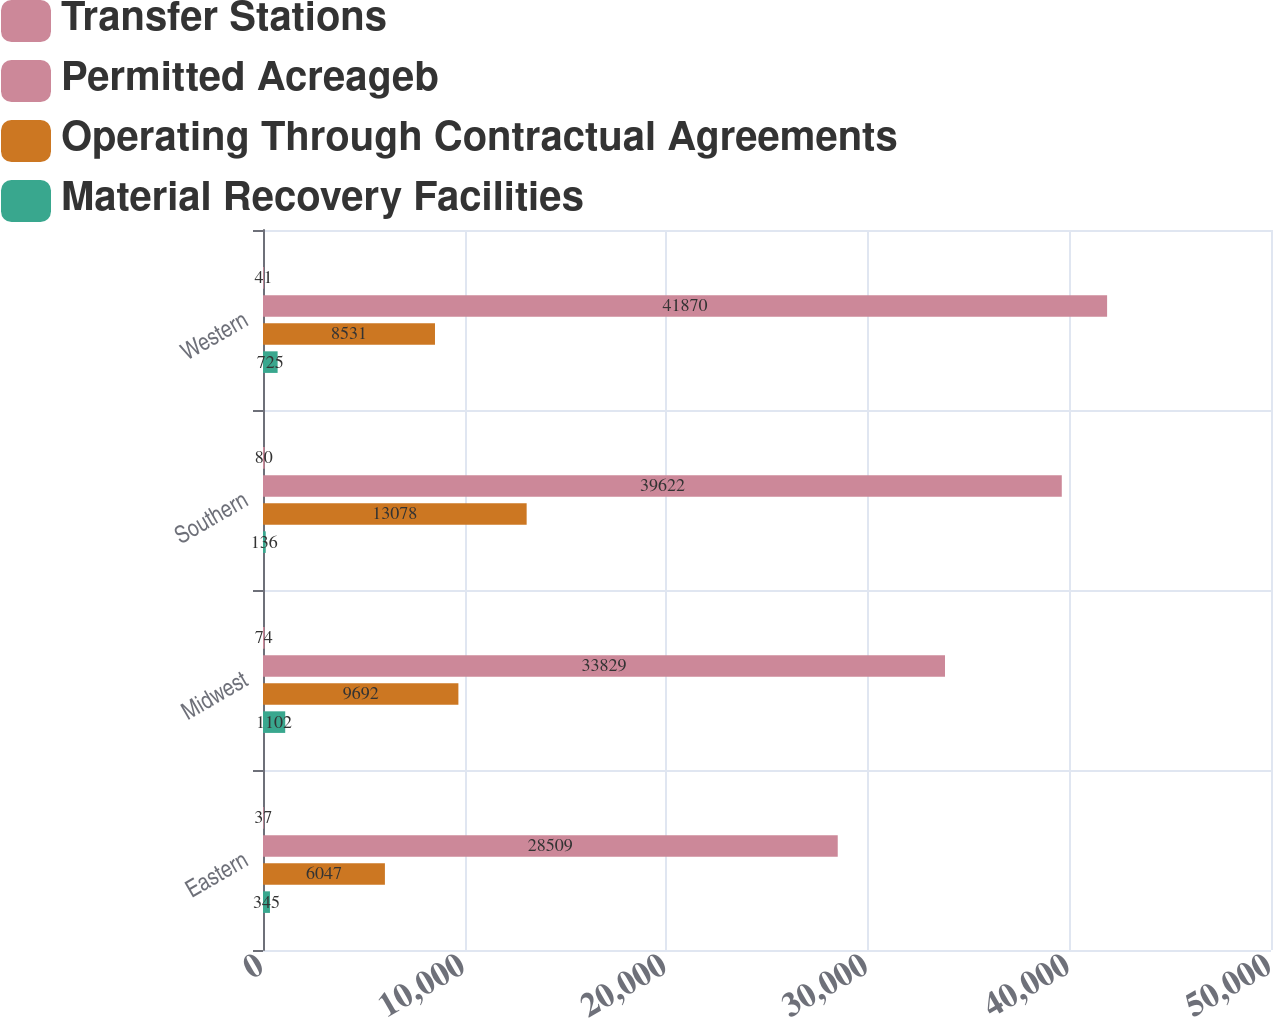Convert chart. <chart><loc_0><loc_0><loc_500><loc_500><stacked_bar_chart><ecel><fcel>Eastern<fcel>Midwest<fcel>Southern<fcel>Western<nl><fcel>Transfer Stations<fcel>37<fcel>74<fcel>80<fcel>41<nl><fcel>Permitted Acreageb<fcel>28509<fcel>33829<fcel>39622<fcel>41870<nl><fcel>Operating Through Contractual Agreements<fcel>6047<fcel>9692<fcel>13078<fcel>8531<nl><fcel>Material Recovery Facilities<fcel>345<fcel>1102<fcel>136<fcel>725<nl></chart> 